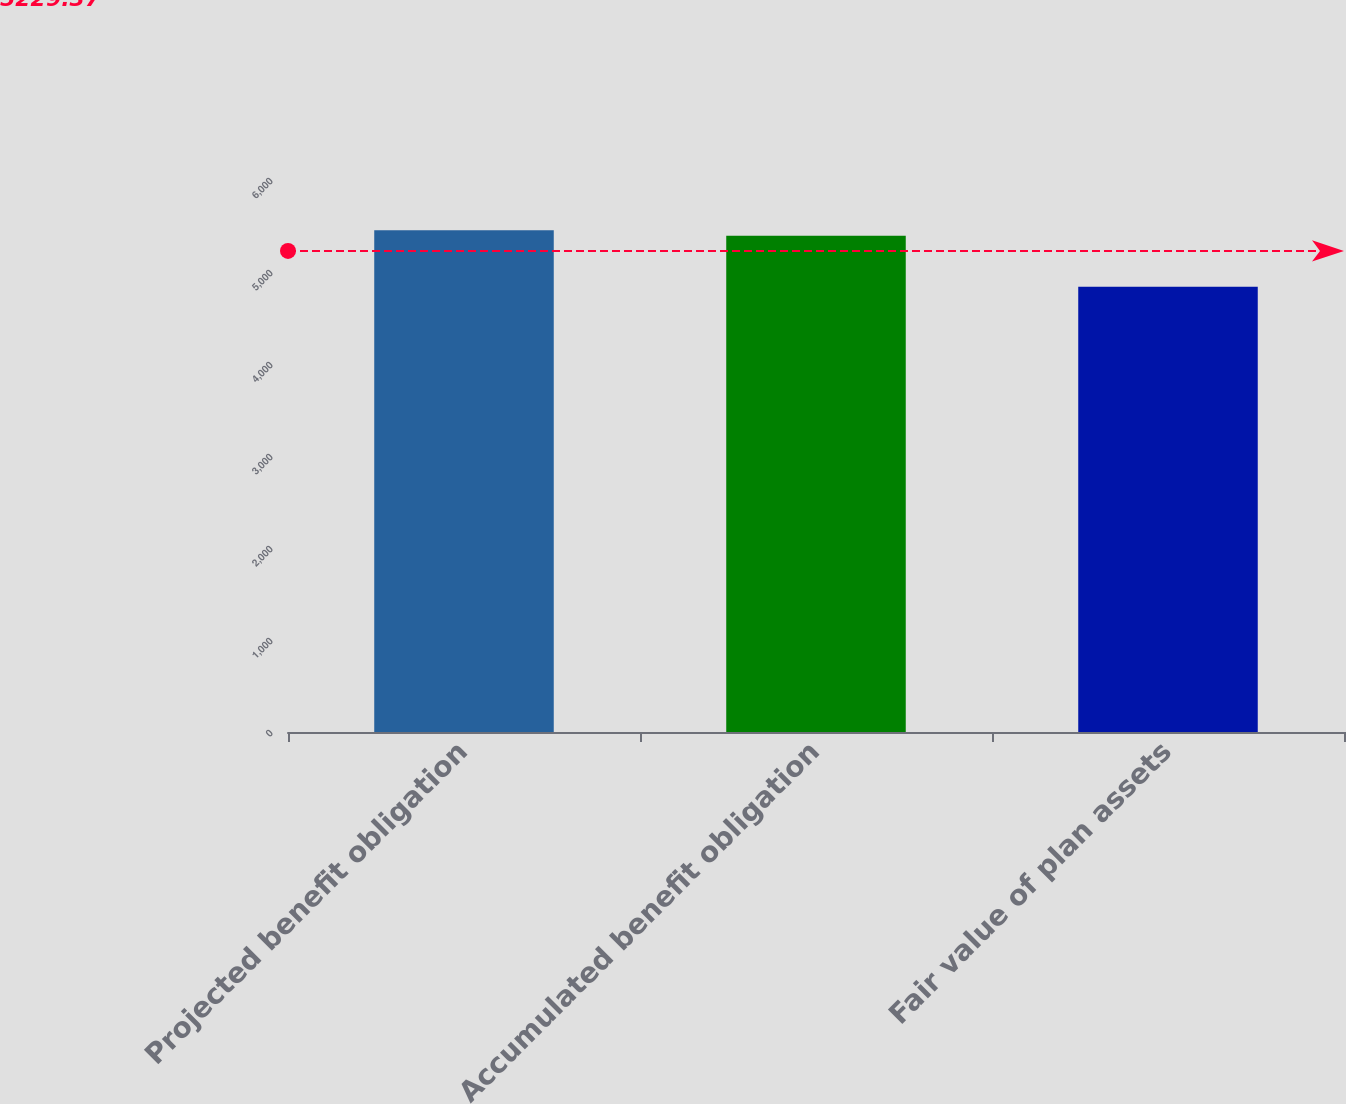Convert chart. <chart><loc_0><loc_0><loc_500><loc_500><bar_chart><fcel>Projected benefit obligation<fcel>Accumulated benefit obligation<fcel>Fair value of plan assets<nl><fcel>5453.1<fcel>5395<fcel>4840<nl></chart> 